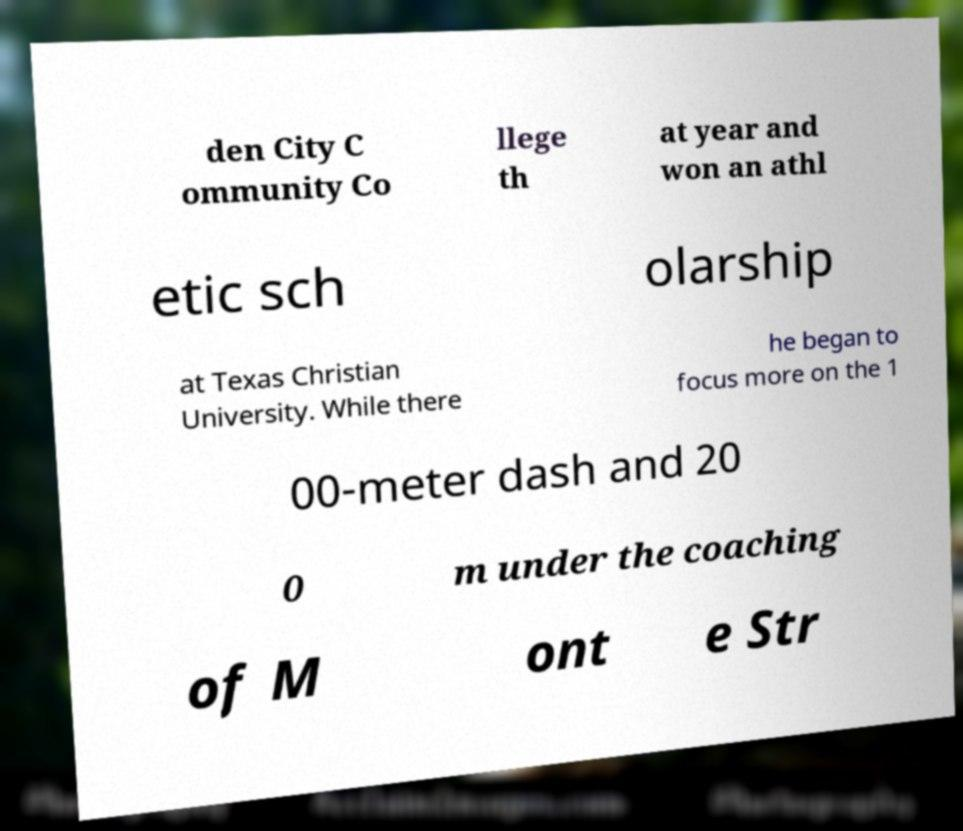Could you assist in decoding the text presented in this image and type it out clearly? den City C ommunity Co llege th at year and won an athl etic sch olarship at Texas Christian University. While there he began to focus more on the 1 00-meter dash and 20 0 m under the coaching of M ont e Str 